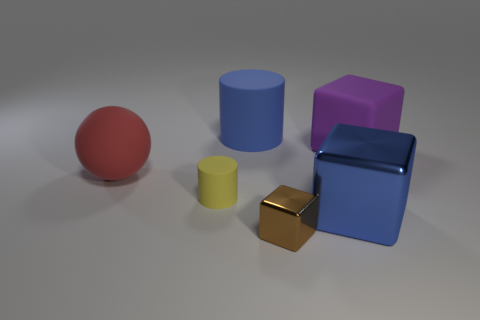Add 3 purple blocks. How many objects exist? 9 Subtract all balls. How many objects are left? 5 Subtract 0 green cubes. How many objects are left? 6 Subtract all rubber blocks. Subtract all brown blocks. How many objects are left? 4 Add 5 big blue rubber cylinders. How many big blue rubber cylinders are left? 6 Add 1 small blocks. How many small blocks exist? 2 